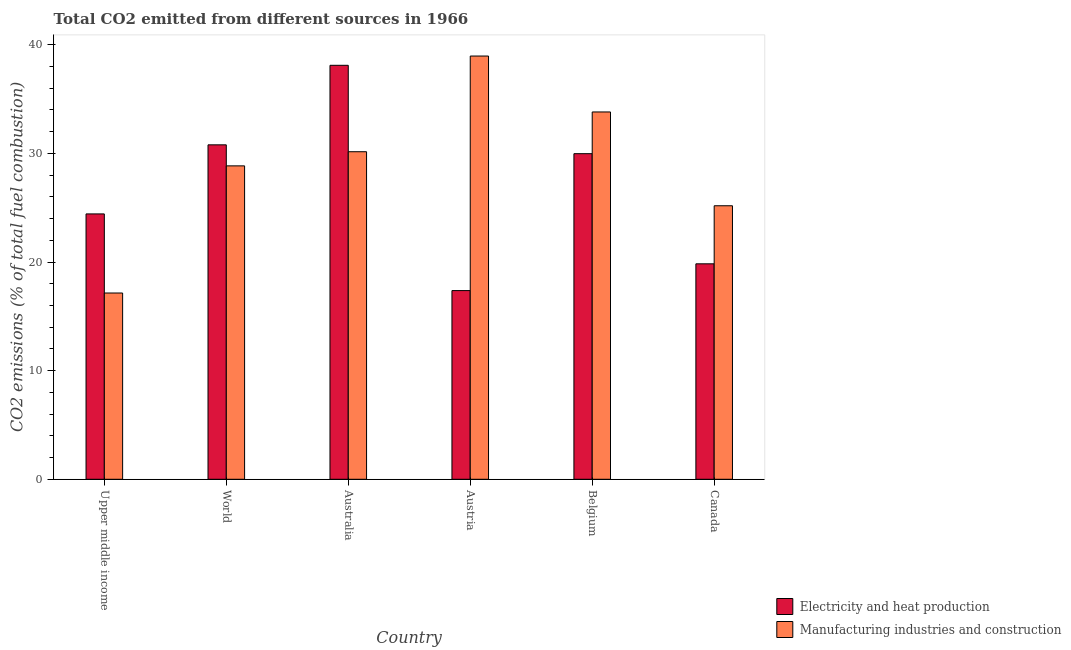How many different coloured bars are there?
Your answer should be compact. 2. How many bars are there on the 5th tick from the left?
Give a very brief answer. 2. How many bars are there on the 1st tick from the right?
Your response must be concise. 2. What is the label of the 1st group of bars from the left?
Provide a short and direct response. Upper middle income. In how many cases, is the number of bars for a given country not equal to the number of legend labels?
Make the answer very short. 0. What is the co2 emissions due to manufacturing industries in Belgium?
Provide a succinct answer. 33.81. Across all countries, what is the maximum co2 emissions due to electricity and heat production?
Keep it short and to the point. 38.11. Across all countries, what is the minimum co2 emissions due to manufacturing industries?
Provide a succinct answer. 17.15. In which country was the co2 emissions due to electricity and heat production maximum?
Your answer should be compact. Australia. In which country was the co2 emissions due to manufacturing industries minimum?
Offer a very short reply. Upper middle income. What is the total co2 emissions due to manufacturing industries in the graph?
Your answer should be very brief. 174.1. What is the difference between the co2 emissions due to electricity and heat production in Austria and that in Upper middle income?
Your answer should be very brief. -7.06. What is the difference between the co2 emissions due to electricity and heat production in Upper middle income and the co2 emissions due to manufacturing industries in Austria?
Give a very brief answer. -14.53. What is the average co2 emissions due to electricity and heat production per country?
Offer a very short reply. 26.75. What is the difference between the co2 emissions due to manufacturing industries and co2 emissions due to electricity and heat production in Australia?
Offer a very short reply. -7.96. In how many countries, is the co2 emissions due to electricity and heat production greater than 24 %?
Ensure brevity in your answer.  4. What is the ratio of the co2 emissions due to manufacturing industries in Austria to that in Canada?
Keep it short and to the point. 1.55. Is the co2 emissions due to electricity and heat production in Australia less than that in World?
Provide a succinct answer. No. What is the difference between the highest and the second highest co2 emissions due to electricity and heat production?
Your response must be concise. 7.32. What is the difference between the highest and the lowest co2 emissions due to electricity and heat production?
Provide a short and direct response. 20.74. What does the 1st bar from the left in Upper middle income represents?
Make the answer very short. Electricity and heat production. What does the 2nd bar from the right in World represents?
Your response must be concise. Electricity and heat production. Are all the bars in the graph horizontal?
Make the answer very short. No. What is the title of the graph?
Your response must be concise. Total CO2 emitted from different sources in 1966. Does "RDB concessional" appear as one of the legend labels in the graph?
Offer a very short reply. No. What is the label or title of the X-axis?
Give a very brief answer. Country. What is the label or title of the Y-axis?
Your answer should be compact. CO2 emissions (% of total fuel combustion). What is the CO2 emissions (% of total fuel combustion) of Electricity and heat production in Upper middle income?
Provide a short and direct response. 24.43. What is the CO2 emissions (% of total fuel combustion) in Manufacturing industries and construction in Upper middle income?
Offer a very short reply. 17.15. What is the CO2 emissions (% of total fuel combustion) in Electricity and heat production in World?
Offer a very short reply. 30.79. What is the CO2 emissions (% of total fuel combustion) in Manufacturing industries and construction in World?
Your response must be concise. 28.85. What is the CO2 emissions (% of total fuel combustion) in Electricity and heat production in Australia?
Your response must be concise. 38.11. What is the CO2 emissions (% of total fuel combustion) in Manufacturing industries and construction in Australia?
Ensure brevity in your answer.  30.15. What is the CO2 emissions (% of total fuel combustion) in Electricity and heat production in Austria?
Give a very brief answer. 17.37. What is the CO2 emissions (% of total fuel combustion) of Manufacturing industries and construction in Austria?
Your response must be concise. 38.96. What is the CO2 emissions (% of total fuel combustion) in Electricity and heat production in Belgium?
Keep it short and to the point. 29.97. What is the CO2 emissions (% of total fuel combustion) in Manufacturing industries and construction in Belgium?
Your response must be concise. 33.81. What is the CO2 emissions (% of total fuel combustion) of Electricity and heat production in Canada?
Keep it short and to the point. 19.83. What is the CO2 emissions (% of total fuel combustion) in Manufacturing industries and construction in Canada?
Offer a terse response. 25.18. Across all countries, what is the maximum CO2 emissions (% of total fuel combustion) of Electricity and heat production?
Give a very brief answer. 38.11. Across all countries, what is the maximum CO2 emissions (% of total fuel combustion) of Manufacturing industries and construction?
Your answer should be compact. 38.96. Across all countries, what is the minimum CO2 emissions (% of total fuel combustion) in Electricity and heat production?
Keep it short and to the point. 17.37. Across all countries, what is the minimum CO2 emissions (% of total fuel combustion) in Manufacturing industries and construction?
Your answer should be compact. 17.15. What is the total CO2 emissions (% of total fuel combustion) of Electricity and heat production in the graph?
Your answer should be very brief. 160.5. What is the total CO2 emissions (% of total fuel combustion) of Manufacturing industries and construction in the graph?
Offer a terse response. 174.1. What is the difference between the CO2 emissions (% of total fuel combustion) in Electricity and heat production in Upper middle income and that in World?
Your response must be concise. -6.36. What is the difference between the CO2 emissions (% of total fuel combustion) of Manufacturing industries and construction in Upper middle income and that in World?
Provide a succinct answer. -11.7. What is the difference between the CO2 emissions (% of total fuel combustion) in Electricity and heat production in Upper middle income and that in Australia?
Offer a very short reply. -13.68. What is the difference between the CO2 emissions (% of total fuel combustion) of Manufacturing industries and construction in Upper middle income and that in Australia?
Your response must be concise. -13. What is the difference between the CO2 emissions (% of total fuel combustion) in Electricity and heat production in Upper middle income and that in Austria?
Your response must be concise. 7.06. What is the difference between the CO2 emissions (% of total fuel combustion) in Manufacturing industries and construction in Upper middle income and that in Austria?
Ensure brevity in your answer.  -21.81. What is the difference between the CO2 emissions (% of total fuel combustion) of Electricity and heat production in Upper middle income and that in Belgium?
Your answer should be very brief. -5.55. What is the difference between the CO2 emissions (% of total fuel combustion) of Manufacturing industries and construction in Upper middle income and that in Belgium?
Offer a very short reply. -16.67. What is the difference between the CO2 emissions (% of total fuel combustion) in Electricity and heat production in Upper middle income and that in Canada?
Provide a succinct answer. 4.59. What is the difference between the CO2 emissions (% of total fuel combustion) of Manufacturing industries and construction in Upper middle income and that in Canada?
Your response must be concise. -8.03. What is the difference between the CO2 emissions (% of total fuel combustion) in Electricity and heat production in World and that in Australia?
Offer a very short reply. -7.32. What is the difference between the CO2 emissions (% of total fuel combustion) of Manufacturing industries and construction in World and that in Australia?
Your answer should be very brief. -1.3. What is the difference between the CO2 emissions (% of total fuel combustion) in Electricity and heat production in World and that in Austria?
Keep it short and to the point. 13.42. What is the difference between the CO2 emissions (% of total fuel combustion) in Manufacturing industries and construction in World and that in Austria?
Your answer should be compact. -10.11. What is the difference between the CO2 emissions (% of total fuel combustion) in Electricity and heat production in World and that in Belgium?
Your answer should be compact. 0.81. What is the difference between the CO2 emissions (% of total fuel combustion) in Manufacturing industries and construction in World and that in Belgium?
Offer a terse response. -4.96. What is the difference between the CO2 emissions (% of total fuel combustion) in Electricity and heat production in World and that in Canada?
Keep it short and to the point. 10.95. What is the difference between the CO2 emissions (% of total fuel combustion) in Manufacturing industries and construction in World and that in Canada?
Keep it short and to the point. 3.67. What is the difference between the CO2 emissions (% of total fuel combustion) in Electricity and heat production in Australia and that in Austria?
Make the answer very short. 20.74. What is the difference between the CO2 emissions (% of total fuel combustion) of Manufacturing industries and construction in Australia and that in Austria?
Give a very brief answer. -8.81. What is the difference between the CO2 emissions (% of total fuel combustion) in Electricity and heat production in Australia and that in Belgium?
Give a very brief answer. 8.14. What is the difference between the CO2 emissions (% of total fuel combustion) in Manufacturing industries and construction in Australia and that in Belgium?
Provide a succinct answer. -3.66. What is the difference between the CO2 emissions (% of total fuel combustion) in Electricity and heat production in Australia and that in Canada?
Ensure brevity in your answer.  18.27. What is the difference between the CO2 emissions (% of total fuel combustion) in Manufacturing industries and construction in Australia and that in Canada?
Offer a terse response. 4.97. What is the difference between the CO2 emissions (% of total fuel combustion) of Electricity and heat production in Austria and that in Belgium?
Provide a succinct answer. -12.6. What is the difference between the CO2 emissions (% of total fuel combustion) of Manufacturing industries and construction in Austria and that in Belgium?
Your answer should be compact. 5.15. What is the difference between the CO2 emissions (% of total fuel combustion) in Electricity and heat production in Austria and that in Canada?
Provide a short and direct response. -2.46. What is the difference between the CO2 emissions (% of total fuel combustion) in Manufacturing industries and construction in Austria and that in Canada?
Provide a succinct answer. 13.78. What is the difference between the CO2 emissions (% of total fuel combustion) of Electricity and heat production in Belgium and that in Canada?
Your answer should be very brief. 10.14. What is the difference between the CO2 emissions (% of total fuel combustion) in Manufacturing industries and construction in Belgium and that in Canada?
Ensure brevity in your answer.  8.63. What is the difference between the CO2 emissions (% of total fuel combustion) in Electricity and heat production in Upper middle income and the CO2 emissions (% of total fuel combustion) in Manufacturing industries and construction in World?
Offer a very short reply. -4.42. What is the difference between the CO2 emissions (% of total fuel combustion) in Electricity and heat production in Upper middle income and the CO2 emissions (% of total fuel combustion) in Manufacturing industries and construction in Australia?
Offer a very short reply. -5.72. What is the difference between the CO2 emissions (% of total fuel combustion) of Electricity and heat production in Upper middle income and the CO2 emissions (% of total fuel combustion) of Manufacturing industries and construction in Austria?
Your response must be concise. -14.53. What is the difference between the CO2 emissions (% of total fuel combustion) in Electricity and heat production in Upper middle income and the CO2 emissions (% of total fuel combustion) in Manufacturing industries and construction in Belgium?
Ensure brevity in your answer.  -9.39. What is the difference between the CO2 emissions (% of total fuel combustion) of Electricity and heat production in Upper middle income and the CO2 emissions (% of total fuel combustion) of Manufacturing industries and construction in Canada?
Provide a succinct answer. -0.75. What is the difference between the CO2 emissions (% of total fuel combustion) of Electricity and heat production in World and the CO2 emissions (% of total fuel combustion) of Manufacturing industries and construction in Australia?
Make the answer very short. 0.63. What is the difference between the CO2 emissions (% of total fuel combustion) in Electricity and heat production in World and the CO2 emissions (% of total fuel combustion) in Manufacturing industries and construction in Austria?
Provide a succinct answer. -8.17. What is the difference between the CO2 emissions (% of total fuel combustion) in Electricity and heat production in World and the CO2 emissions (% of total fuel combustion) in Manufacturing industries and construction in Belgium?
Your answer should be very brief. -3.03. What is the difference between the CO2 emissions (% of total fuel combustion) in Electricity and heat production in World and the CO2 emissions (% of total fuel combustion) in Manufacturing industries and construction in Canada?
Ensure brevity in your answer.  5.61. What is the difference between the CO2 emissions (% of total fuel combustion) in Electricity and heat production in Australia and the CO2 emissions (% of total fuel combustion) in Manufacturing industries and construction in Austria?
Provide a succinct answer. -0.85. What is the difference between the CO2 emissions (% of total fuel combustion) in Electricity and heat production in Australia and the CO2 emissions (% of total fuel combustion) in Manufacturing industries and construction in Belgium?
Keep it short and to the point. 4.29. What is the difference between the CO2 emissions (% of total fuel combustion) of Electricity and heat production in Australia and the CO2 emissions (% of total fuel combustion) of Manufacturing industries and construction in Canada?
Provide a succinct answer. 12.93. What is the difference between the CO2 emissions (% of total fuel combustion) of Electricity and heat production in Austria and the CO2 emissions (% of total fuel combustion) of Manufacturing industries and construction in Belgium?
Your answer should be very brief. -16.44. What is the difference between the CO2 emissions (% of total fuel combustion) in Electricity and heat production in Austria and the CO2 emissions (% of total fuel combustion) in Manufacturing industries and construction in Canada?
Give a very brief answer. -7.81. What is the difference between the CO2 emissions (% of total fuel combustion) in Electricity and heat production in Belgium and the CO2 emissions (% of total fuel combustion) in Manufacturing industries and construction in Canada?
Give a very brief answer. 4.79. What is the average CO2 emissions (% of total fuel combustion) of Electricity and heat production per country?
Provide a succinct answer. 26.75. What is the average CO2 emissions (% of total fuel combustion) of Manufacturing industries and construction per country?
Ensure brevity in your answer.  29.02. What is the difference between the CO2 emissions (% of total fuel combustion) of Electricity and heat production and CO2 emissions (% of total fuel combustion) of Manufacturing industries and construction in Upper middle income?
Give a very brief answer. 7.28. What is the difference between the CO2 emissions (% of total fuel combustion) in Electricity and heat production and CO2 emissions (% of total fuel combustion) in Manufacturing industries and construction in World?
Your answer should be compact. 1.94. What is the difference between the CO2 emissions (% of total fuel combustion) in Electricity and heat production and CO2 emissions (% of total fuel combustion) in Manufacturing industries and construction in Australia?
Give a very brief answer. 7.96. What is the difference between the CO2 emissions (% of total fuel combustion) in Electricity and heat production and CO2 emissions (% of total fuel combustion) in Manufacturing industries and construction in Austria?
Your response must be concise. -21.59. What is the difference between the CO2 emissions (% of total fuel combustion) in Electricity and heat production and CO2 emissions (% of total fuel combustion) in Manufacturing industries and construction in Belgium?
Your answer should be compact. -3.84. What is the difference between the CO2 emissions (% of total fuel combustion) in Electricity and heat production and CO2 emissions (% of total fuel combustion) in Manufacturing industries and construction in Canada?
Keep it short and to the point. -5.35. What is the ratio of the CO2 emissions (% of total fuel combustion) in Electricity and heat production in Upper middle income to that in World?
Offer a terse response. 0.79. What is the ratio of the CO2 emissions (% of total fuel combustion) of Manufacturing industries and construction in Upper middle income to that in World?
Provide a short and direct response. 0.59. What is the ratio of the CO2 emissions (% of total fuel combustion) in Electricity and heat production in Upper middle income to that in Australia?
Make the answer very short. 0.64. What is the ratio of the CO2 emissions (% of total fuel combustion) of Manufacturing industries and construction in Upper middle income to that in Australia?
Your answer should be compact. 0.57. What is the ratio of the CO2 emissions (% of total fuel combustion) of Electricity and heat production in Upper middle income to that in Austria?
Your response must be concise. 1.41. What is the ratio of the CO2 emissions (% of total fuel combustion) of Manufacturing industries and construction in Upper middle income to that in Austria?
Make the answer very short. 0.44. What is the ratio of the CO2 emissions (% of total fuel combustion) in Electricity and heat production in Upper middle income to that in Belgium?
Your response must be concise. 0.81. What is the ratio of the CO2 emissions (% of total fuel combustion) in Manufacturing industries and construction in Upper middle income to that in Belgium?
Give a very brief answer. 0.51. What is the ratio of the CO2 emissions (% of total fuel combustion) of Electricity and heat production in Upper middle income to that in Canada?
Offer a very short reply. 1.23. What is the ratio of the CO2 emissions (% of total fuel combustion) in Manufacturing industries and construction in Upper middle income to that in Canada?
Ensure brevity in your answer.  0.68. What is the ratio of the CO2 emissions (% of total fuel combustion) of Electricity and heat production in World to that in Australia?
Your response must be concise. 0.81. What is the ratio of the CO2 emissions (% of total fuel combustion) in Manufacturing industries and construction in World to that in Australia?
Ensure brevity in your answer.  0.96. What is the ratio of the CO2 emissions (% of total fuel combustion) in Electricity and heat production in World to that in Austria?
Offer a terse response. 1.77. What is the ratio of the CO2 emissions (% of total fuel combustion) in Manufacturing industries and construction in World to that in Austria?
Offer a very short reply. 0.74. What is the ratio of the CO2 emissions (% of total fuel combustion) of Electricity and heat production in World to that in Belgium?
Your answer should be very brief. 1.03. What is the ratio of the CO2 emissions (% of total fuel combustion) in Manufacturing industries and construction in World to that in Belgium?
Provide a short and direct response. 0.85. What is the ratio of the CO2 emissions (% of total fuel combustion) of Electricity and heat production in World to that in Canada?
Offer a very short reply. 1.55. What is the ratio of the CO2 emissions (% of total fuel combustion) of Manufacturing industries and construction in World to that in Canada?
Your answer should be very brief. 1.15. What is the ratio of the CO2 emissions (% of total fuel combustion) in Electricity and heat production in Australia to that in Austria?
Keep it short and to the point. 2.19. What is the ratio of the CO2 emissions (% of total fuel combustion) of Manufacturing industries and construction in Australia to that in Austria?
Keep it short and to the point. 0.77. What is the ratio of the CO2 emissions (% of total fuel combustion) of Electricity and heat production in Australia to that in Belgium?
Offer a terse response. 1.27. What is the ratio of the CO2 emissions (% of total fuel combustion) in Manufacturing industries and construction in Australia to that in Belgium?
Give a very brief answer. 0.89. What is the ratio of the CO2 emissions (% of total fuel combustion) of Electricity and heat production in Australia to that in Canada?
Ensure brevity in your answer.  1.92. What is the ratio of the CO2 emissions (% of total fuel combustion) of Manufacturing industries and construction in Australia to that in Canada?
Your answer should be very brief. 1.2. What is the ratio of the CO2 emissions (% of total fuel combustion) in Electricity and heat production in Austria to that in Belgium?
Provide a succinct answer. 0.58. What is the ratio of the CO2 emissions (% of total fuel combustion) of Manufacturing industries and construction in Austria to that in Belgium?
Your answer should be compact. 1.15. What is the ratio of the CO2 emissions (% of total fuel combustion) of Electricity and heat production in Austria to that in Canada?
Provide a short and direct response. 0.88. What is the ratio of the CO2 emissions (% of total fuel combustion) in Manufacturing industries and construction in Austria to that in Canada?
Give a very brief answer. 1.55. What is the ratio of the CO2 emissions (% of total fuel combustion) of Electricity and heat production in Belgium to that in Canada?
Provide a succinct answer. 1.51. What is the ratio of the CO2 emissions (% of total fuel combustion) in Manufacturing industries and construction in Belgium to that in Canada?
Give a very brief answer. 1.34. What is the difference between the highest and the second highest CO2 emissions (% of total fuel combustion) of Electricity and heat production?
Provide a short and direct response. 7.32. What is the difference between the highest and the second highest CO2 emissions (% of total fuel combustion) of Manufacturing industries and construction?
Give a very brief answer. 5.15. What is the difference between the highest and the lowest CO2 emissions (% of total fuel combustion) of Electricity and heat production?
Offer a very short reply. 20.74. What is the difference between the highest and the lowest CO2 emissions (% of total fuel combustion) in Manufacturing industries and construction?
Your response must be concise. 21.81. 